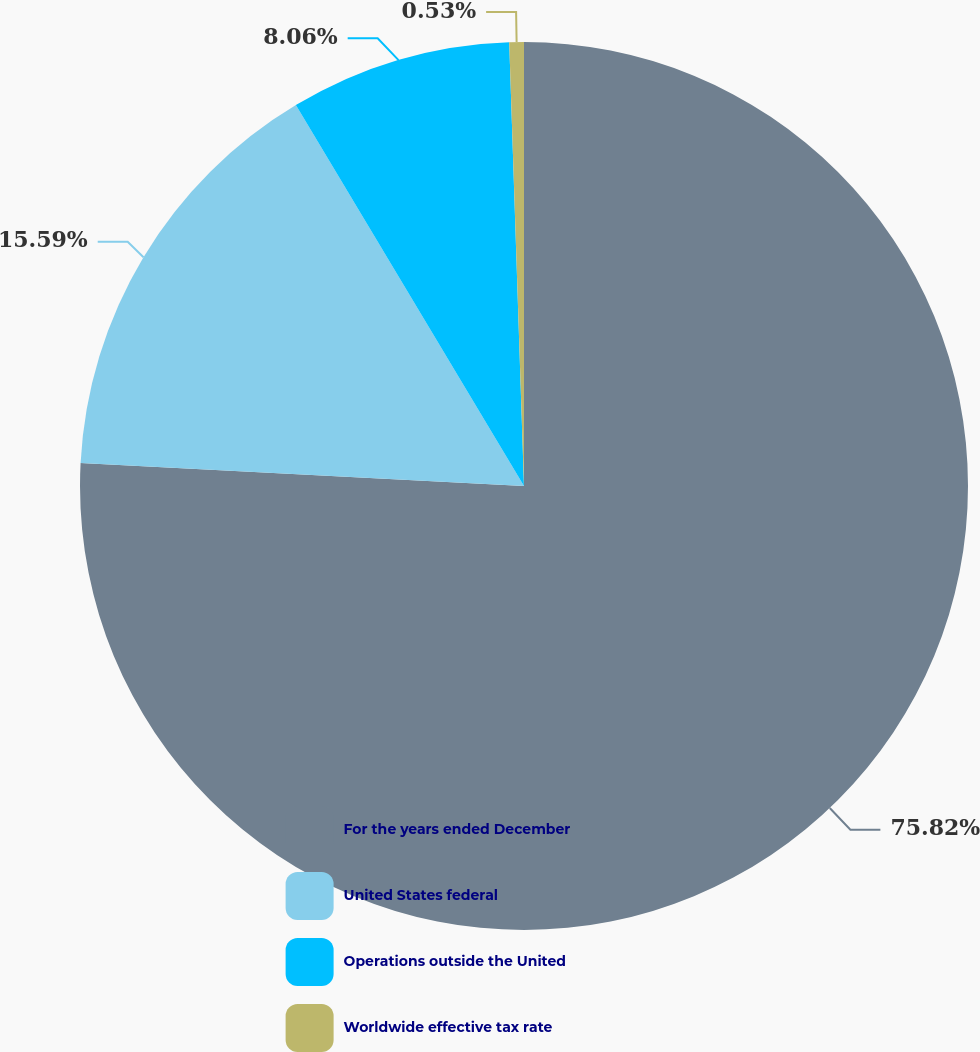Convert chart to OTSL. <chart><loc_0><loc_0><loc_500><loc_500><pie_chart><fcel>For the years ended December<fcel>United States federal<fcel>Operations outside the United<fcel>Worldwide effective tax rate<nl><fcel>75.83%<fcel>15.59%<fcel>8.06%<fcel>0.53%<nl></chart> 